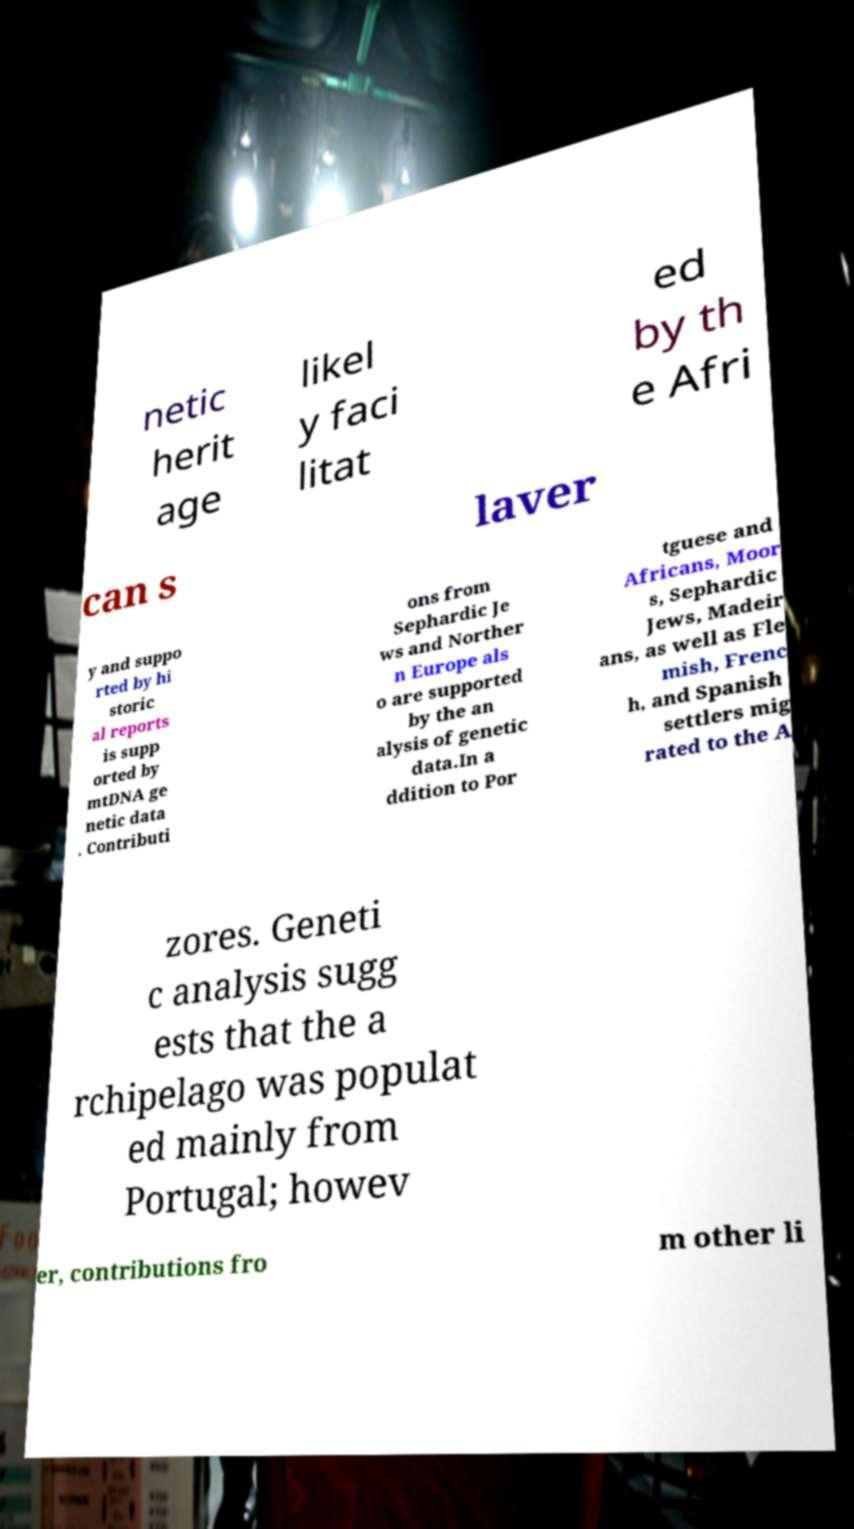There's text embedded in this image that I need extracted. Can you transcribe it verbatim? netic herit age likel y faci litat ed by th e Afri can s laver y and suppo rted by hi storic al reports is supp orted by mtDNA ge netic data . Contributi ons from Sephardic Je ws and Norther n Europe als o are supported by the an alysis of genetic data.In a ddition to Por tguese and Africans, Moor s, Sephardic Jews, Madeir ans, as well as Fle mish, Frenc h, and Spanish settlers mig rated to the A zores. Geneti c analysis sugg ests that the a rchipelago was populat ed mainly from Portugal; howev er, contributions fro m other li 